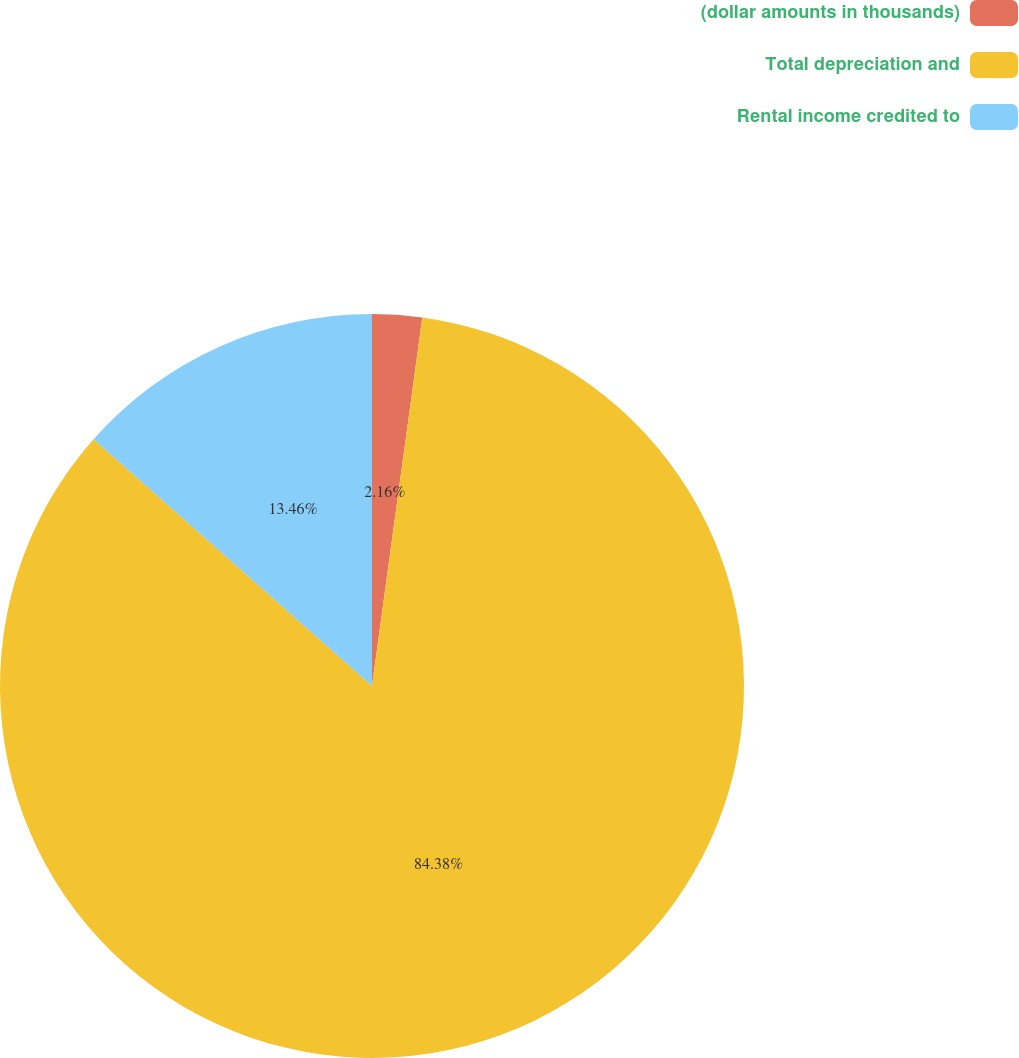Convert chart. <chart><loc_0><loc_0><loc_500><loc_500><pie_chart><fcel>(dollar amounts in thousands)<fcel>Total depreciation and<fcel>Rental income credited to<nl><fcel>2.16%<fcel>84.38%<fcel>13.46%<nl></chart> 